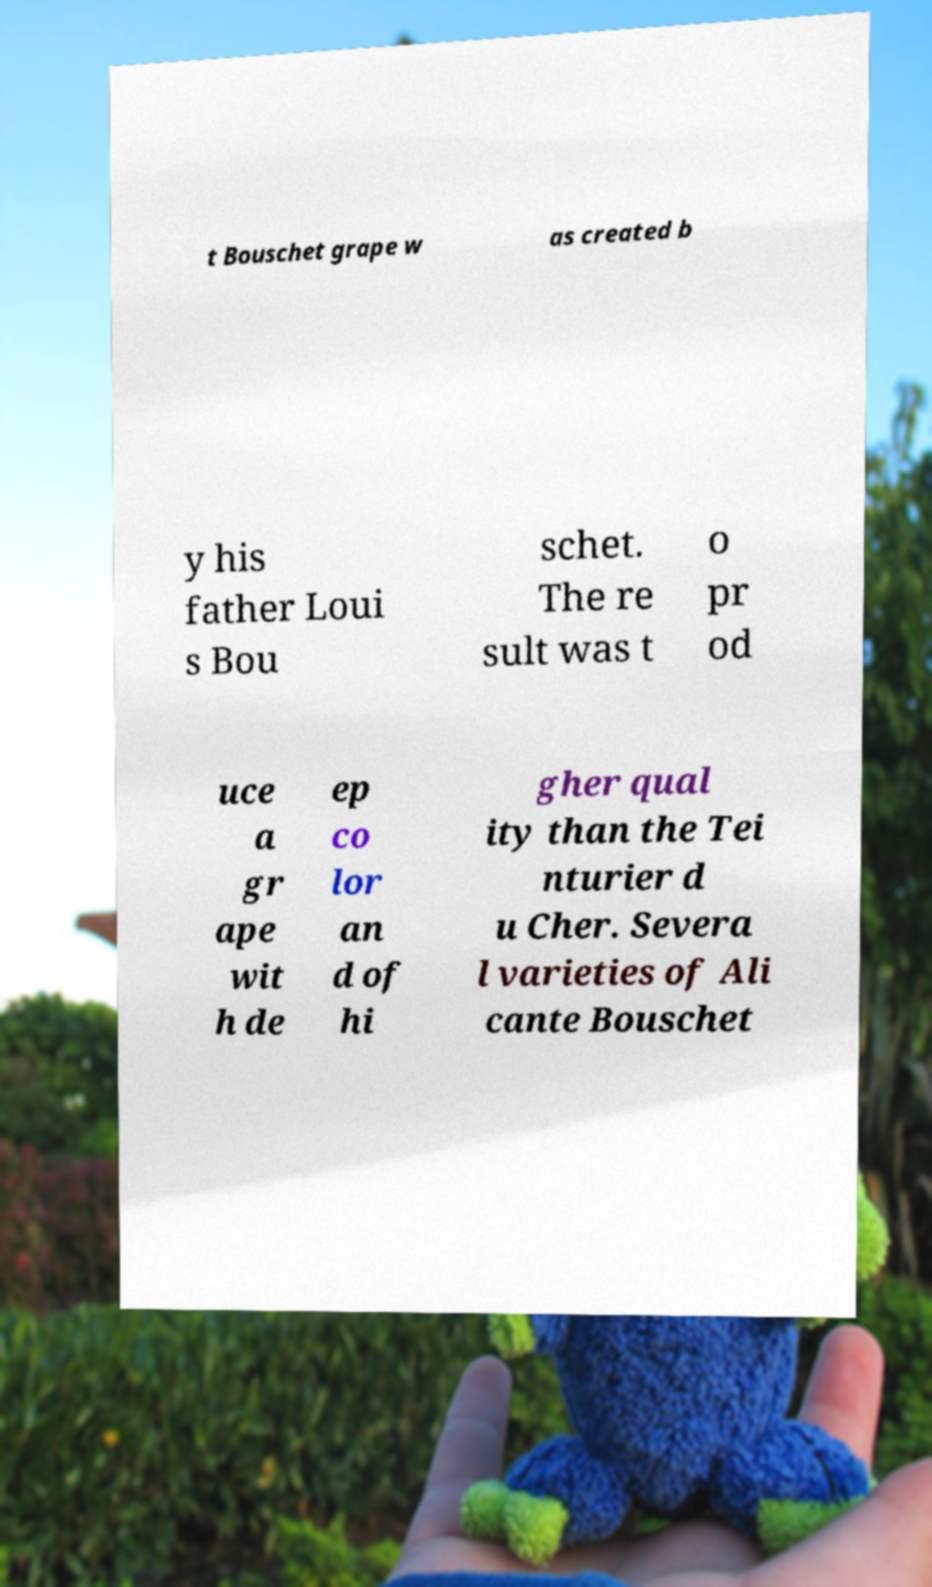Can you accurately transcribe the text from the provided image for me? t Bouschet grape w as created b y his father Loui s Bou schet. The re sult was t o pr od uce a gr ape wit h de ep co lor an d of hi gher qual ity than the Tei nturier d u Cher. Severa l varieties of Ali cante Bouschet 